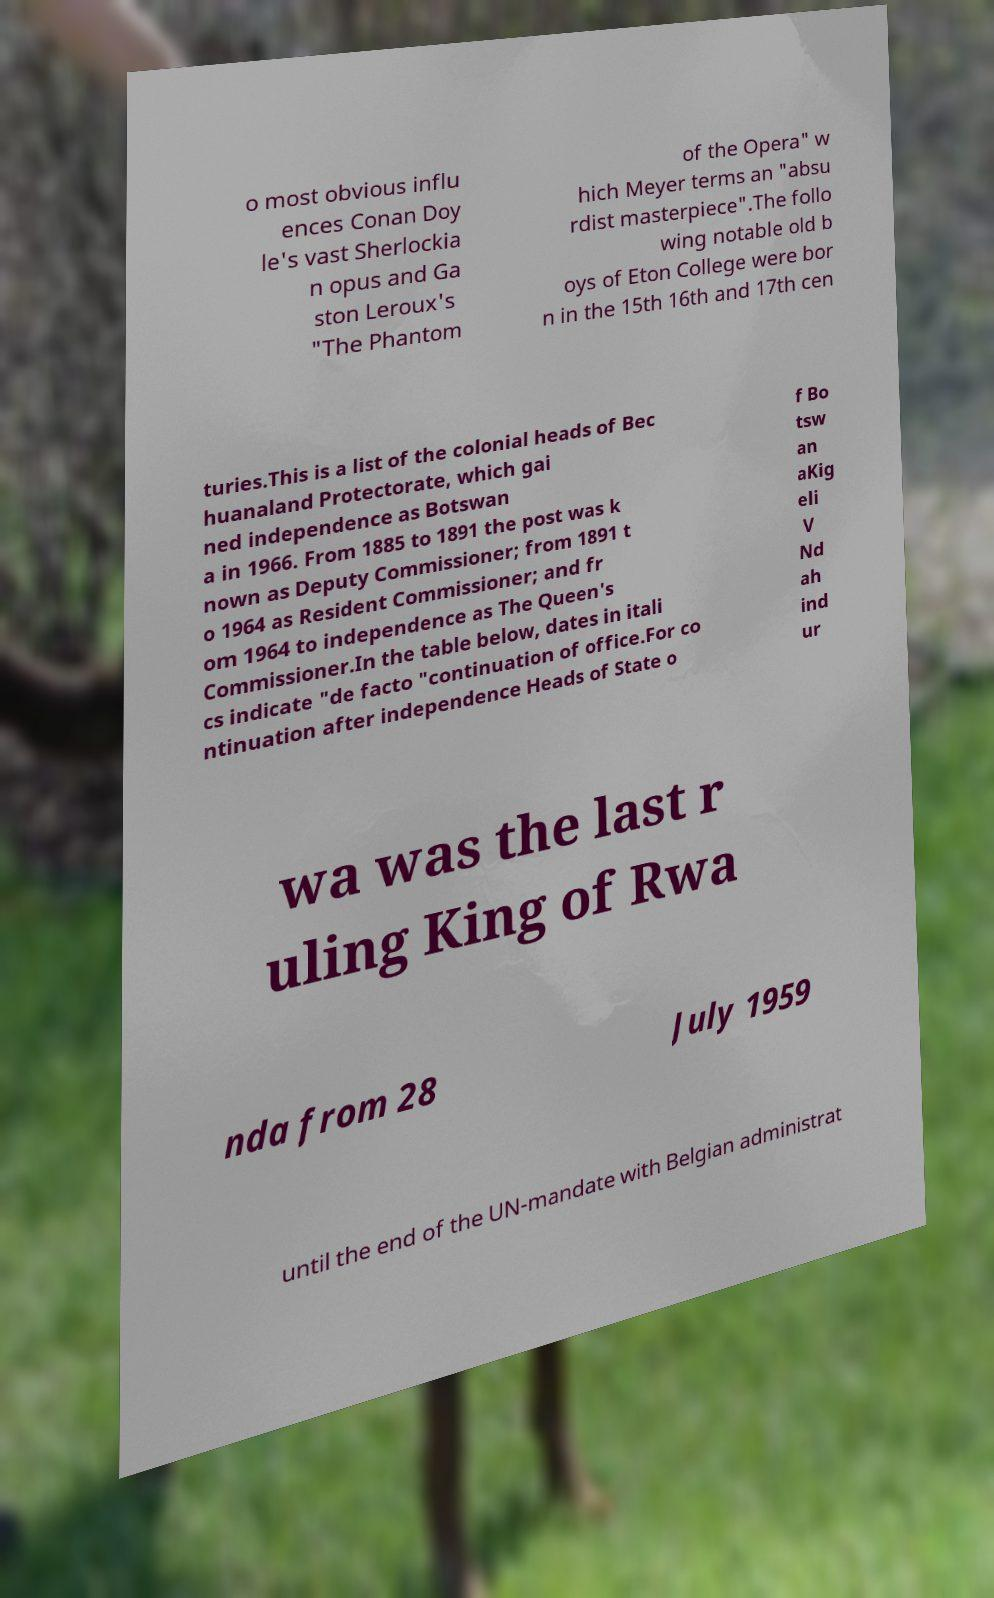Could you assist in decoding the text presented in this image and type it out clearly? o most obvious influ ences Conan Doy le's vast Sherlockia n opus and Ga ston Leroux's "The Phantom of the Opera" w hich Meyer terms an "absu rdist masterpiece".The follo wing notable old b oys of Eton College were bor n in the 15th 16th and 17th cen turies.This is a list of the colonial heads of Bec huanaland Protectorate, which gai ned independence as Botswan a in 1966. From 1885 to 1891 the post was k nown as Deputy Commissioner; from 1891 t o 1964 as Resident Commissioner; and fr om 1964 to independence as The Queen's Commissioner.In the table below, dates in itali cs indicate "de facto "continuation of office.For co ntinuation after independence Heads of State o f Bo tsw an aKig eli V Nd ah ind ur wa was the last r uling King of Rwa nda from 28 July 1959 until the end of the UN-mandate with Belgian administrat 